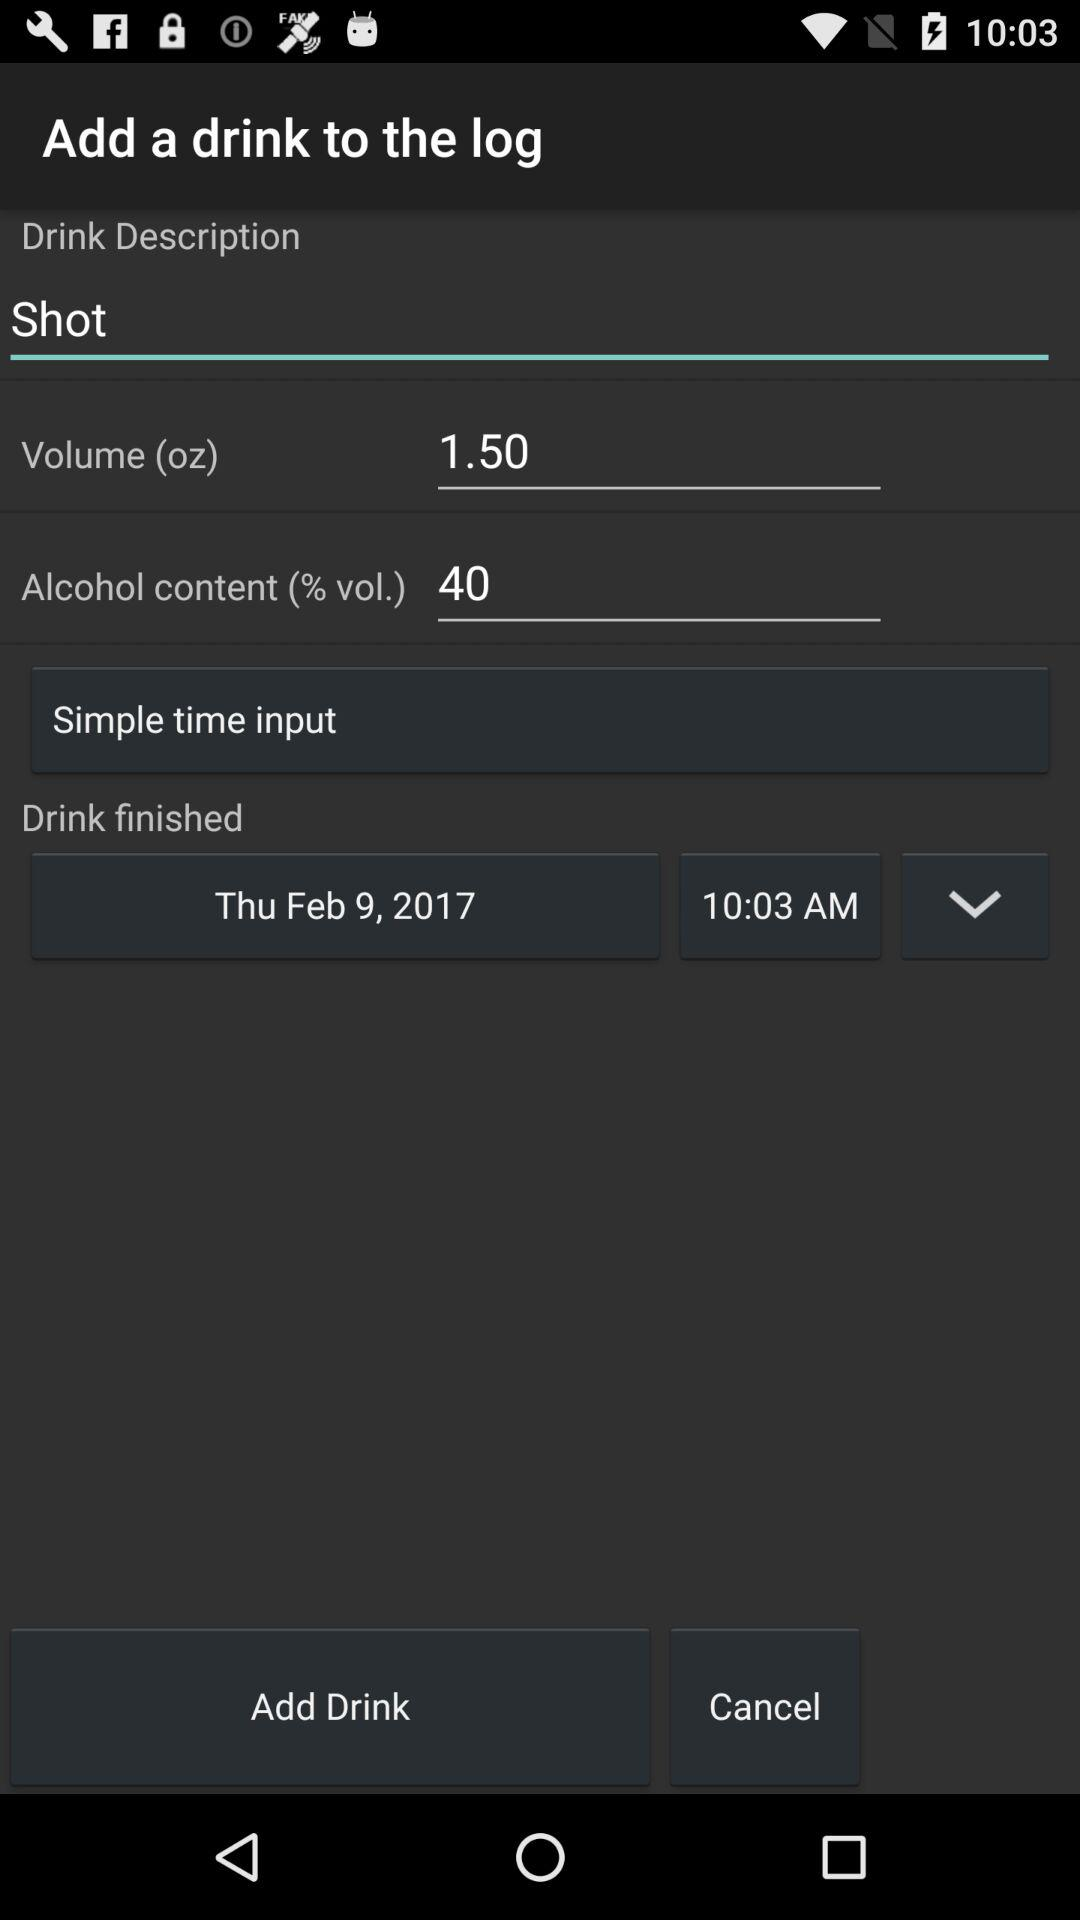What is the alcohol content percentage? The alcohol content is 40 percent. 